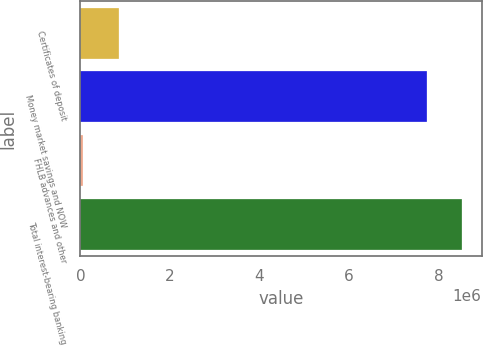Convert chart. <chart><loc_0><loc_0><loc_500><loc_500><bar_chart><fcel>Certificates of deposit<fcel>Money market savings and NOW<fcel>FHLB advances and other<fcel>Total interest-bearing banking<nl><fcel>855111<fcel>7.73609e+06<fcel>51834<fcel>8.53937e+06<nl></chart> 